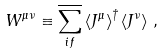<formula> <loc_0><loc_0><loc_500><loc_500>W ^ { \mu \nu } \equiv \overline { \sum _ { i f } } \left < J ^ { \mu } \right > ^ { \dagger } \left < J ^ { \nu } \right > \, ,</formula> 